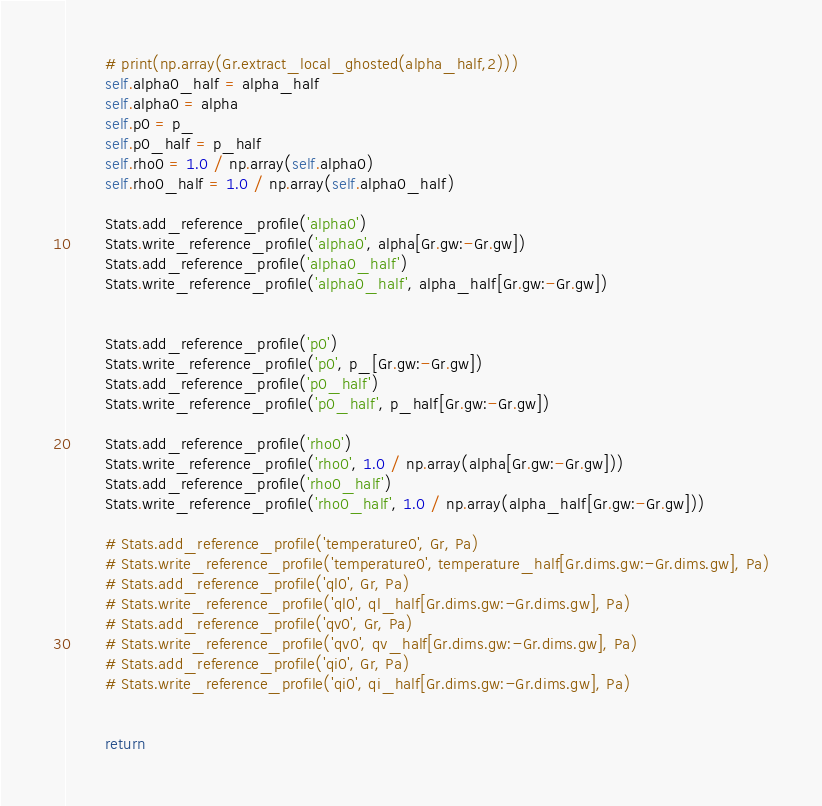Convert code to text. <code><loc_0><loc_0><loc_500><loc_500><_Cython_>



        # print(np.array(Gr.extract_local_ghosted(alpha_half,2)))
        self.alpha0_half = alpha_half
        self.alpha0 = alpha
        self.p0 = p_
        self.p0_half = p_half
        self.rho0 = 1.0 / np.array(self.alpha0)
        self.rho0_half = 1.0 / np.array(self.alpha0_half)

        Stats.add_reference_profile('alpha0')
        Stats.write_reference_profile('alpha0', alpha[Gr.gw:-Gr.gw])
        Stats.add_reference_profile('alpha0_half')
        Stats.write_reference_profile('alpha0_half', alpha_half[Gr.gw:-Gr.gw])


        Stats.add_reference_profile('p0')
        Stats.write_reference_profile('p0', p_[Gr.gw:-Gr.gw])
        Stats.add_reference_profile('p0_half')
        Stats.write_reference_profile('p0_half', p_half[Gr.gw:-Gr.gw])

        Stats.add_reference_profile('rho0')
        Stats.write_reference_profile('rho0', 1.0 / np.array(alpha[Gr.gw:-Gr.gw]))
        Stats.add_reference_profile('rho0_half')
        Stats.write_reference_profile('rho0_half', 1.0 / np.array(alpha_half[Gr.gw:-Gr.gw]))

        # Stats.add_reference_profile('temperature0', Gr, Pa)
        # Stats.write_reference_profile('temperature0', temperature_half[Gr.dims.gw:-Gr.dims.gw], Pa)
        # Stats.add_reference_profile('ql0', Gr, Pa)
        # Stats.write_reference_profile('ql0', ql_half[Gr.dims.gw:-Gr.dims.gw], Pa)
        # Stats.add_reference_profile('qv0', Gr, Pa)
        # Stats.write_reference_profile('qv0', qv_half[Gr.dims.gw:-Gr.dims.gw], Pa)
        # Stats.add_reference_profile('qi0', Gr, Pa)
        # Stats.write_reference_profile('qi0', qi_half[Gr.dims.gw:-Gr.dims.gw], Pa)


        return

</code> 